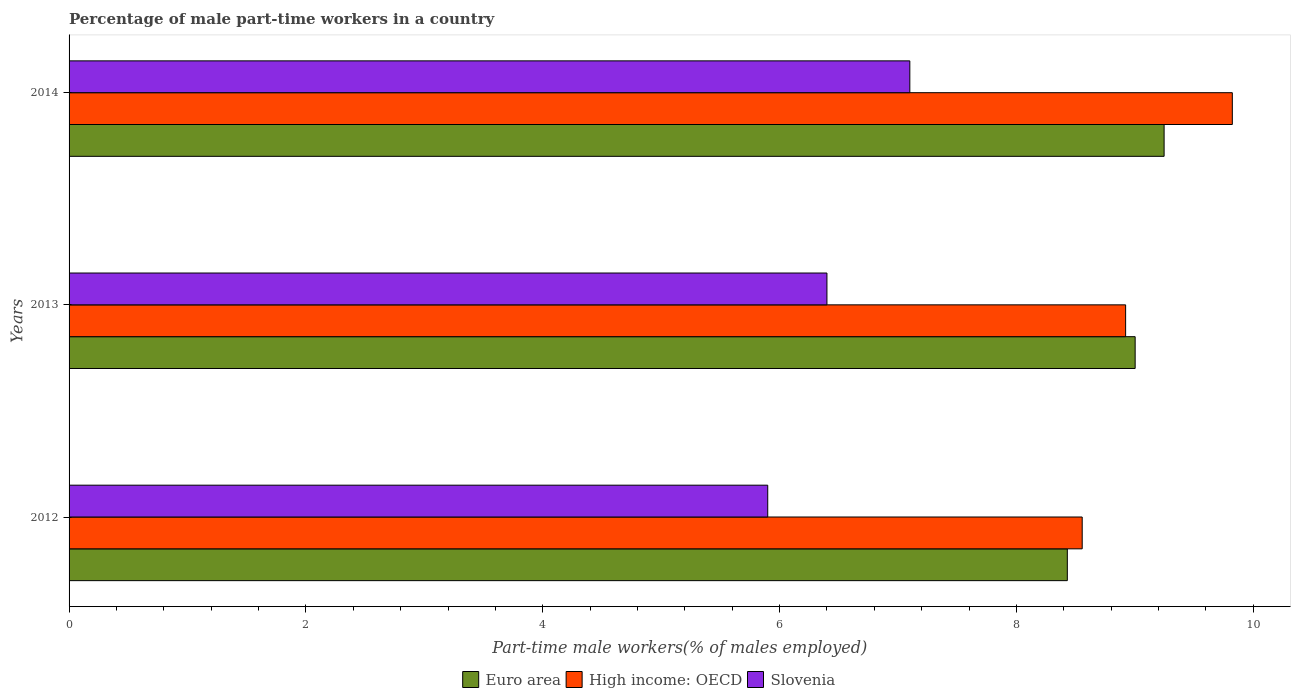How many different coloured bars are there?
Provide a short and direct response. 3. How many groups of bars are there?
Offer a terse response. 3. Are the number of bars per tick equal to the number of legend labels?
Make the answer very short. Yes. Are the number of bars on each tick of the Y-axis equal?
Make the answer very short. Yes. How many bars are there on the 1st tick from the bottom?
Give a very brief answer. 3. What is the percentage of male part-time workers in Euro area in 2013?
Provide a short and direct response. 9. Across all years, what is the maximum percentage of male part-time workers in Slovenia?
Keep it short and to the point. 7.1. Across all years, what is the minimum percentage of male part-time workers in Euro area?
Offer a terse response. 8.43. In which year was the percentage of male part-time workers in High income: OECD minimum?
Keep it short and to the point. 2012. What is the total percentage of male part-time workers in High income: OECD in the graph?
Keep it short and to the point. 27.3. What is the difference between the percentage of male part-time workers in High income: OECD in 2012 and that in 2013?
Give a very brief answer. -0.37. What is the difference between the percentage of male part-time workers in Euro area in 2013 and the percentage of male part-time workers in Slovenia in 2012?
Provide a succinct answer. 3.1. What is the average percentage of male part-time workers in Slovenia per year?
Offer a very short reply. 6.47. In the year 2012, what is the difference between the percentage of male part-time workers in Slovenia and percentage of male part-time workers in High income: OECD?
Provide a succinct answer. -2.66. What is the ratio of the percentage of male part-time workers in Slovenia in 2012 to that in 2014?
Make the answer very short. 0.83. What is the difference between the highest and the second highest percentage of male part-time workers in High income: OECD?
Offer a terse response. 0.9. What is the difference between the highest and the lowest percentage of male part-time workers in Euro area?
Offer a terse response. 0.82. Is the sum of the percentage of male part-time workers in Slovenia in 2012 and 2014 greater than the maximum percentage of male part-time workers in Euro area across all years?
Ensure brevity in your answer.  Yes. What does the 2nd bar from the top in 2012 represents?
Your answer should be very brief. High income: OECD. What does the 2nd bar from the bottom in 2013 represents?
Your response must be concise. High income: OECD. How many bars are there?
Make the answer very short. 9. Are all the bars in the graph horizontal?
Make the answer very short. Yes. How many years are there in the graph?
Provide a succinct answer. 3. What is the difference between two consecutive major ticks on the X-axis?
Offer a terse response. 2. Are the values on the major ticks of X-axis written in scientific E-notation?
Your answer should be compact. No. Where does the legend appear in the graph?
Your response must be concise. Bottom center. How are the legend labels stacked?
Make the answer very short. Horizontal. What is the title of the graph?
Your answer should be compact. Percentage of male part-time workers in a country. What is the label or title of the X-axis?
Your answer should be compact. Part-time male workers(% of males employed). What is the Part-time male workers(% of males employed) of Euro area in 2012?
Keep it short and to the point. 8.43. What is the Part-time male workers(% of males employed) in High income: OECD in 2012?
Your response must be concise. 8.56. What is the Part-time male workers(% of males employed) of Slovenia in 2012?
Keep it short and to the point. 5.9. What is the Part-time male workers(% of males employed) of Euro area in 2013?
Offer a terse response. 9. What is the Part-time male workers(% of males employed) of High income: OECD in 2013?
Your answer should be compact. 8.92. What is the Part-time male workers(% of males employed) of Slovenia in 2013?
Your answer should be compact. 6.4. What is the Part-time male workers(% of males employed) of Euro area in 2014?
Give a very brief answer. 9.25. What is the Part-time male workers(% of males employed) of High income: OECD in 2014?
Keep it short and to the point. 9.82. What is the Part-time male workers(% of males employed) in Slovenia in 2014?
Provide a succinct answer. 7.1. Across all years, what is the maximum Part-time male workers(% of males employed) in Euro area?
Keep it short and to the point. 9.25. Across all years, what is the maximum Part-time male workers(% of males employed) in High income: OECD?
Provide a succinct answer. 9.82. Across all years, what is the maximum Part-time male workers(% of males employed) in Slovenia?
Make the answer very short. 7.1. Across all years, what is the minimum Part-time male workers(% of males employed) in Euro area?
Your answer should be compact. 8.43. Across all years, what is the minimum Part-time male workers(% of males employed) of High income: OECD?
Keep it short and to the point. 8.56. Across all years, what is the minimum Part-time male workers(% of males employed) in Slovenia?
Ensure brevity in your answer.  5.9. What is the total Part-time male workers(% of males employed) in Euro area in the graph?
Your answer should be very brief. 26.68. What is the total Part-time male workers(% of males employed) of High income: OECD in the graph?
Your response must be concise. 27.3. What is the difference between the Part-time male workers(% of males employed) of Euro area in 2012 and that in 2013?
Your answer should be very brief. -0.57. What is the difference between the Part-time male workers(% of males employed) in High income: OECD in 2012 and that in 2013?
Your response must be concise. -0.37. What is the difference between the Part-time male workers(% of males employed) in Slovenia in 2012 and that in 2013?
Give a very brief answer. -0.5. What is the difference between the Part-time male workers(% of males employed) in Euro area in 2012 and that in 2014?
Keep it short and to the point. -0.82. What is the difference between the Part-time male workers(% of males employed) in High income: OECD in 2012 and that in 2014?
Your response must be concise. -1.27. What is the difference between the Part-time male workers(% of males employed) in Slovenia in 2012 and that in 2014?
Offer a very short reply. -1.2. What is the difference between the Part-time male workers(% of males employed) of Euro area in 2013 and that in 2014?
Offer a terse response. -0.24. What is the difference between the Part-time male workers(% of males employed) in High income: OECD in 2013 and that in 2014?
Make the answer very short. -0.9. What is the difference between the Part-time male workers(% of males employed) in Slovenia in 2013 and that in 2014?
Your answer should be very brief. -0.7. What is the difference between the Part-time male workers(% of males employed) in Euro area in 2012 and the Part-time male workers(% of males employed) in High income: OECD in 2013?
Ensure brevity in your answer.  -0.49. What is the difference between the Part-time male workers(% of males employed) in Euro area in 2012 and the Part-time male workers(% of males employed) in Slovenia in 2013?
Keep it short and to the point. 2.03. What is the difference between the Part-time male workers(% of males employed) in High income: OECD in 2012 and the Part-time male workers(% of males employed) in Slovenia in 2013?
Provide a short and direct response. 2.16. What is the difference between the Part-time male workers(% of males employed) in Euro area in 2012 and the Part-time male workers(% of males employed) in High income: OECD in 2014?
Your answer should be very brief. -1.39. What is the difference between the Part-time male workers(% of males employed) in Euro area in 2012 and the Part-time male workers(% of males employed) in Slovenia in 2014?
Your answer should be compact. 1.33. What is the difference between the Part-time male workers(% of males employed) in High income: OECD in 2012 and the Part-time male workers(% of males employed) in Slovenia in 2014?
Make the answer very short. 1.46. What is the difference between the Part-time male workers(% of males employed) of Euro area in 2013 and the Part-time male workers(% of males employed) of High income: OECD in 2014?
Provide a succinct answer. -0.82. What is the difference between the Part-time male workers(% of males employed) of Euro area in 2013 and the Part-time male workers(% of males employed) of Slovenia in 2014?
Your response must be concise. 1.9. What is the difference between the Part-time male workers(% of males employed) of High income: OECD in 2013 and the Part-time male workers(% of males employed) of Slovenia in 2014?
Provide a succinct answer. 1.82. What is the average Part-time male workers(% of males employed) in Euro area per year?
Make the answer very short. 8.89. What is the average Part-time male workers(% of males employed) in High income: OECD per year?
Keep it short and to the point. 9.1. What is the average Part-time male workers(% of males employed) of Slovenia per year?
Your answer should be compact. 6.47. In the year 2012, what is the difference between the Part-time male workers(% of males employed) of Euro area and Part-time male workers(% of males employed) of High income: OECD?
Your answer should be very brief. -0.13. In the year 2012, what is the difference between the Part-time male workers(% of males employed) of Euro area and Part-time male workers(% of males employed) of Slovenia?
Offer a very short reply. 2.53. In the year 2012, what is the difference between the Part-time male workers(% of males employed) of High income: OECD and Part-time male workers(% of males employed) of Slovenia?
Offer a terse response. 2.66. In the year 2013, what is the difference between the Part-time male workers(% of males employed) in Euro area and Part-time male workers(% of males employed) in High income: OECD?
Your answer should be compact. 0.08. In the year 2013, what is the difference between the Part-time male workers(% of males employed) of Euro area and Part-time male workers(% of males employed) of Slovenia?
Provide a succinct answer. 2.6. In the year 2013, what is the difference between the Part-time male workers(% of males employed) in High income: OECD and Part-time male workers(% of males employed) in Slovenia?
Ensure brevity in your answer.  2.52. In the year 2014, what is the difference between the Part-time male workers(% of males employed) in Euro area and Part-time male workers(% of males employed) in High income: OECD?
Your answer should be very brief. -0.58. In the year 2014, what is the difference between the Part-time male workers(% of males employed) in Euro area and Part-time male workers(% of males employed) in Slovenia?
Offer a very short reply. 2.15. In the year 2014, what is the difference between the Part-time male workers(% of males employed) in High income: OECD and Part-time male workers(% of males employed) in Slovenia?
Your answer should be very brief. 2.72. What is the ratio of the Part-time male workers(% of males employed) in Euro area in 2012 to that in 2013?
Provide a short and direct response. 0.94. What is the ratio of the Part-time male workers(% of males employed) in High income: OECD in 2012 to that in 2013?
Your answer should be very brief. 0.96. What is the ratio of the Part-time male workers(% of males employed) of Slovenia in 2012 to that in 2013?
Your answer should be very brief. 0.92. What is the ratio of the Part-time male workers(% of males employed) of Euro area in 2012 to that in 2014?
Your answer should be very brief. 0.91. What is the ratio of the Part-time male workers(% of males employed) in High income: OECD in 2012 to that in 2014?
Offer a very short reply. 0.87. What is the ratio of the Part-time male workers(% of males employed) of Slovenia in 2012 to that in 2014?
Provide a succinct answer. 0.83. What is the ratio of the Part-time male workers(% of males employed) of Euro area in 2013 to that in 2014?
Ensure brevity in your answer.  0.97. What is the ratio of the Part-time male workers(% of males employed) of High income: OECD in 2013 to that in 2014?
Offer a terse response. 0.91. What is the ratio of the Part-time male workers(% of males employed) in Slovenia in 2013 to that in 2014?
Offer a terse response. 0.9. What is the difference between the highest and the second highest Part-time male workers(% of males employed) in Euro area?
Your answer should be very brief. 0.24. What is the difference between the highest and the second highest Part-time male workers(% of males employed) in High income: OECD?
Keep it short and to the point. 0.9. What is the difference between the highest and the second highest Part-time male workers(% of males employed) of Slovenia?
Give a very brief answer. 0.7. What is the difference between the highest and the lowest Part-time male workers(% of males employed) in Euro area?
Provide a succinct answer. 0.82. What is the difference between the highest and the lowest Part-time male workers(% of males employed) of High income: OECD?
Offer a very short reply. 1.27. 